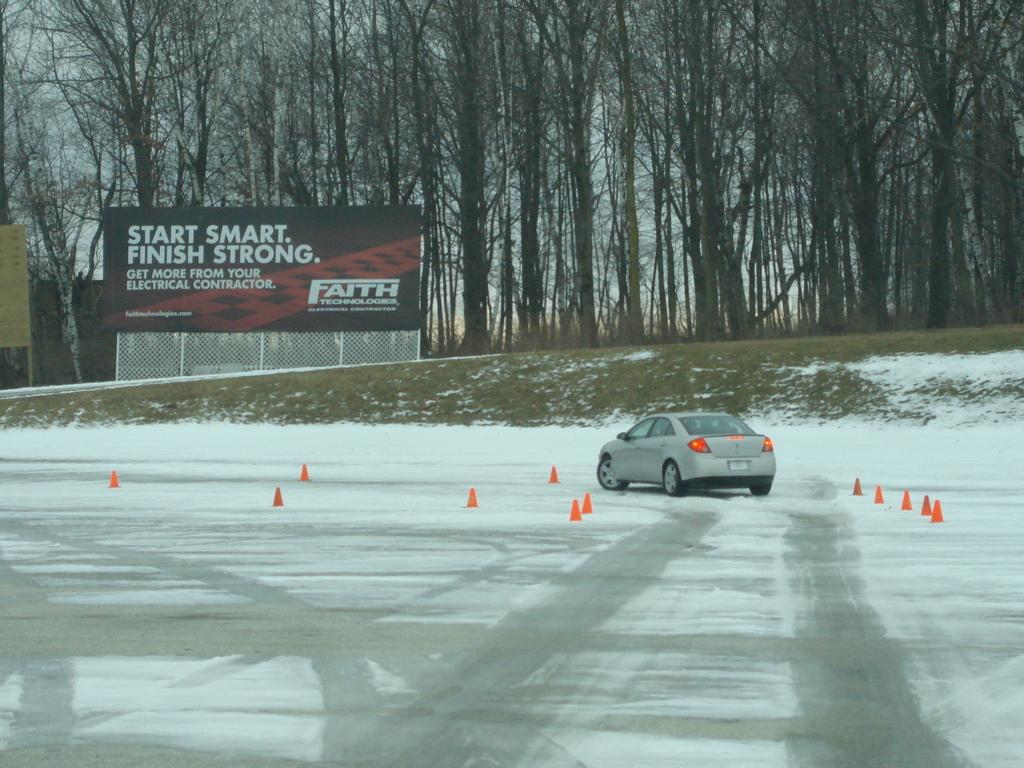What is the primary feature of the image? There is snow in the image. What objects are present on the road? There are traffic cones on the road. What can be seen in the background of the image? There is a vehicle, a fence, a hoarding, trees, and the sky visible in the background of the image. What is located on the left side of the image? There is an object on the left side of the image. What type of cabbage is being used as a mitten in the image? There is no cabbage or mitten present in the image. Can you describe the self-driving capabilities of the vehicle in the image? The image does not provide any information about the vehicle's self-driving capabilities. 